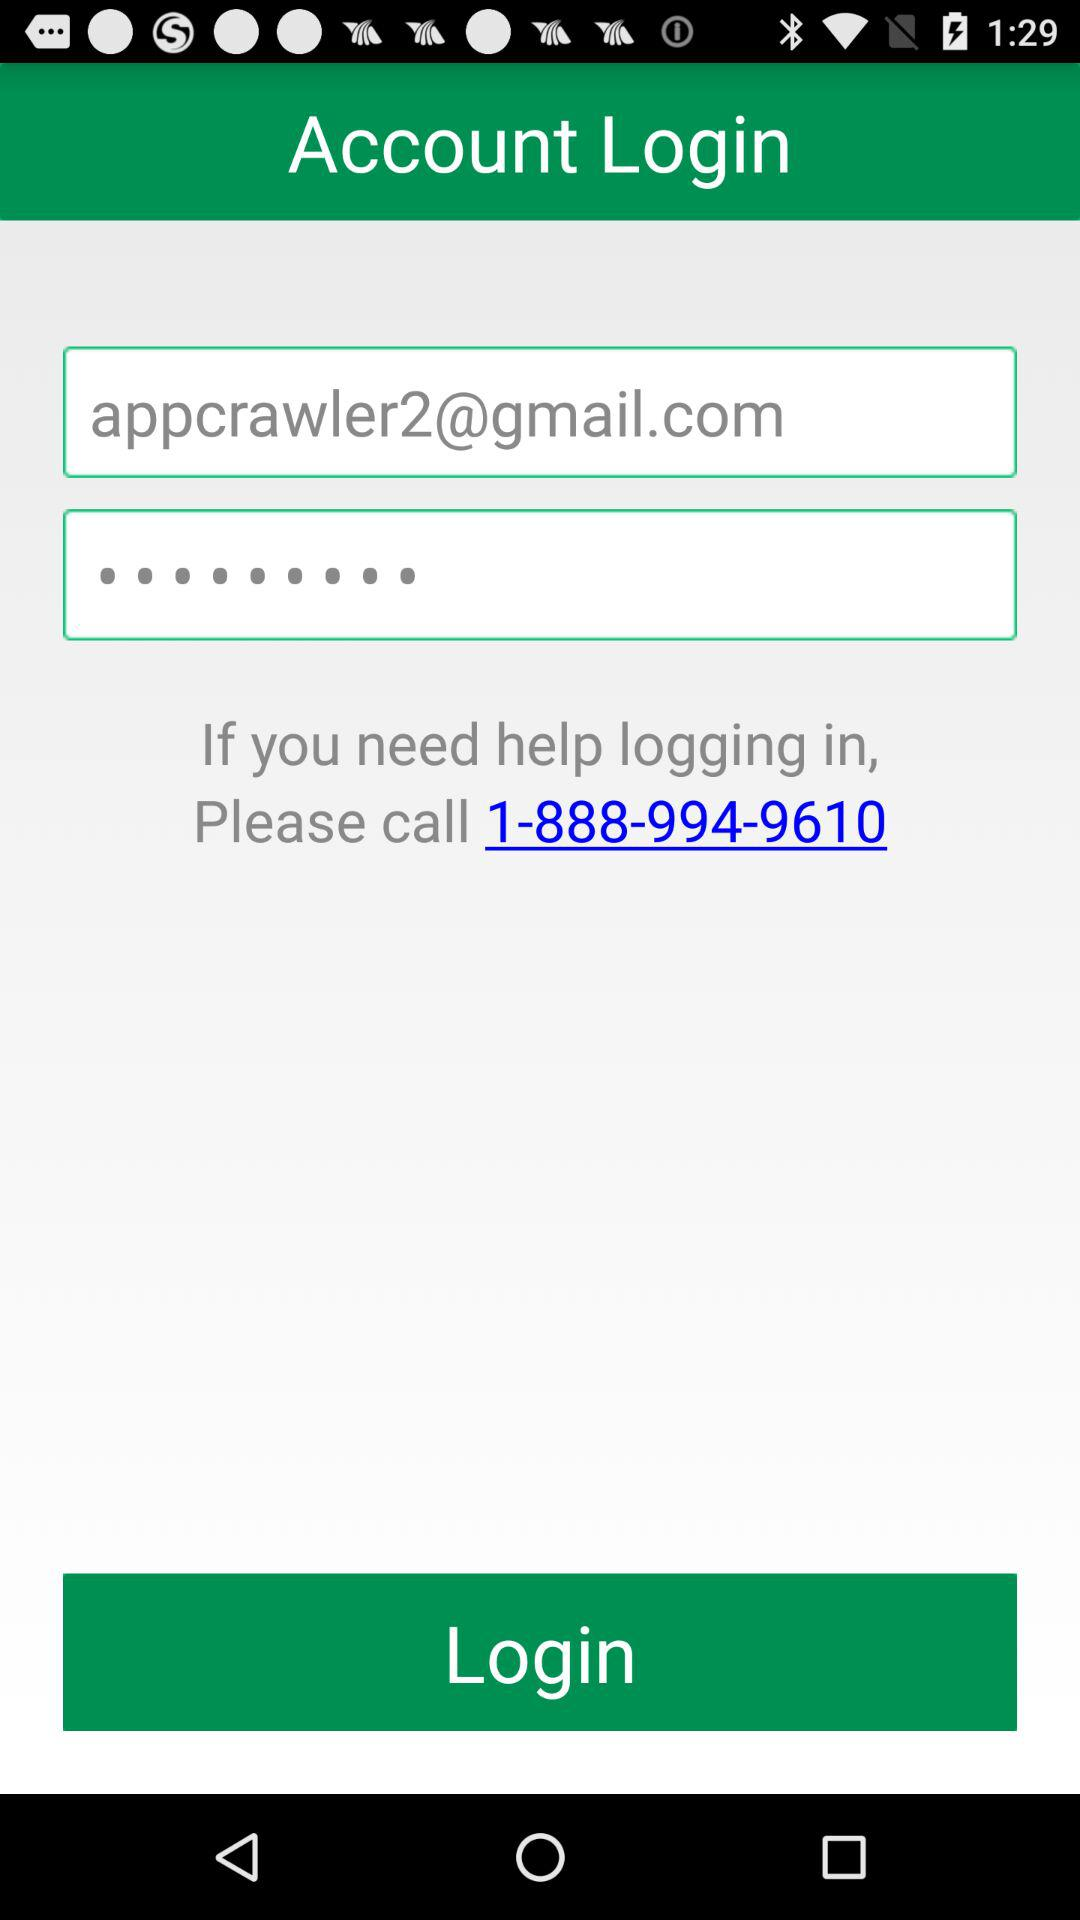What is the login name?
When the provided information is insufficient, respond with <no answer>. <no answer> 